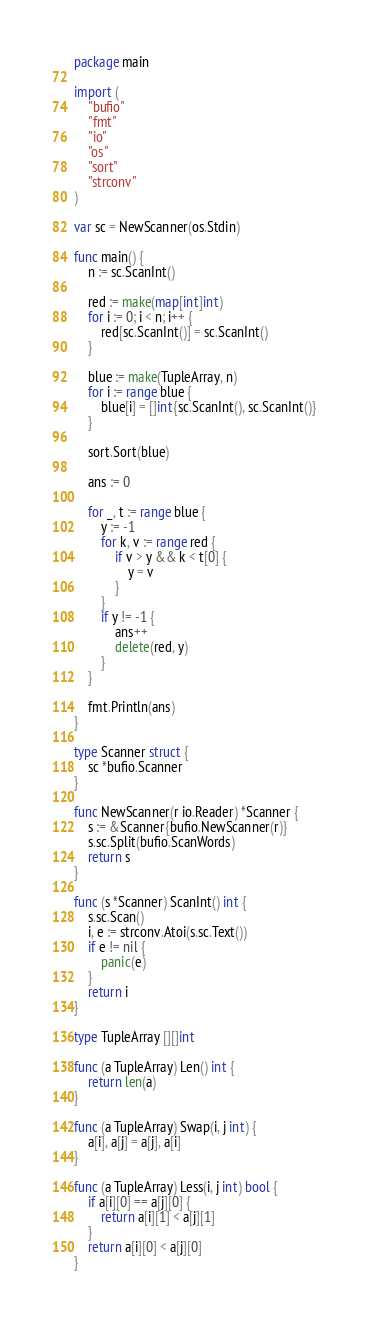Convert code to text. <code><loc_0><loc_0><loc_500><loc_500><_Go_>package main

import (
	"bufio"
	"fmt"
	"io"
	"os"
	"sort"
	"strconv"
)

var sc = NewScanner(os.Stdin)

func main() {
	n := sc.ScanInt()

	red := make(map[int]int)
	for i := 0; i < n; i++ {
		red[sc.ScanInt()] = sc.ScanInt()
	}

	blue := make(TupleArray, n)
	for i := range blue {
		blue[i] = []int{sc.ScanInt(), sc.ScanInt()}
	}

	sort.Sort(blue)

	ans := 0

	for _, t := range blue {
		y := -1
		for k, v := range red {
			if v > y && k < t[0] {
				y = v
			}
		}
		if y != -1 {
			ans++
			delete(red, y)
		}
	}

	fmt.Println(ans)
}

type Scanner struct {
	sc *bufio.Scanner
}

func NewScanner(r io.Reader) *Scanner {
	s := &Scanner{bufio.NewScanner(r)}
	s.sc.Split(bufio.ScanWords)
	return s
}

func (s *Scanner) ScanInt() int {
	s.sc.Scan()
	i, e := strconv.Atoi(s.sc.Text())
	if e != nil {
		panic(e)
	}
	return i
}

type TupleArray [][]int

func (a TupleArray) Len() int {
	return len(a)
}

func (a TupleArray) Swap(i, j int) {
	a[i], a[j] = a[j], a[i]
}

func (a TupleArray) Less(i, j int) bool {
	if a[i][0] == a[j][0] {
		return a[i][1] < a[j][1]
	}
	return a[i][0] < a[j][0]
}
</code> 